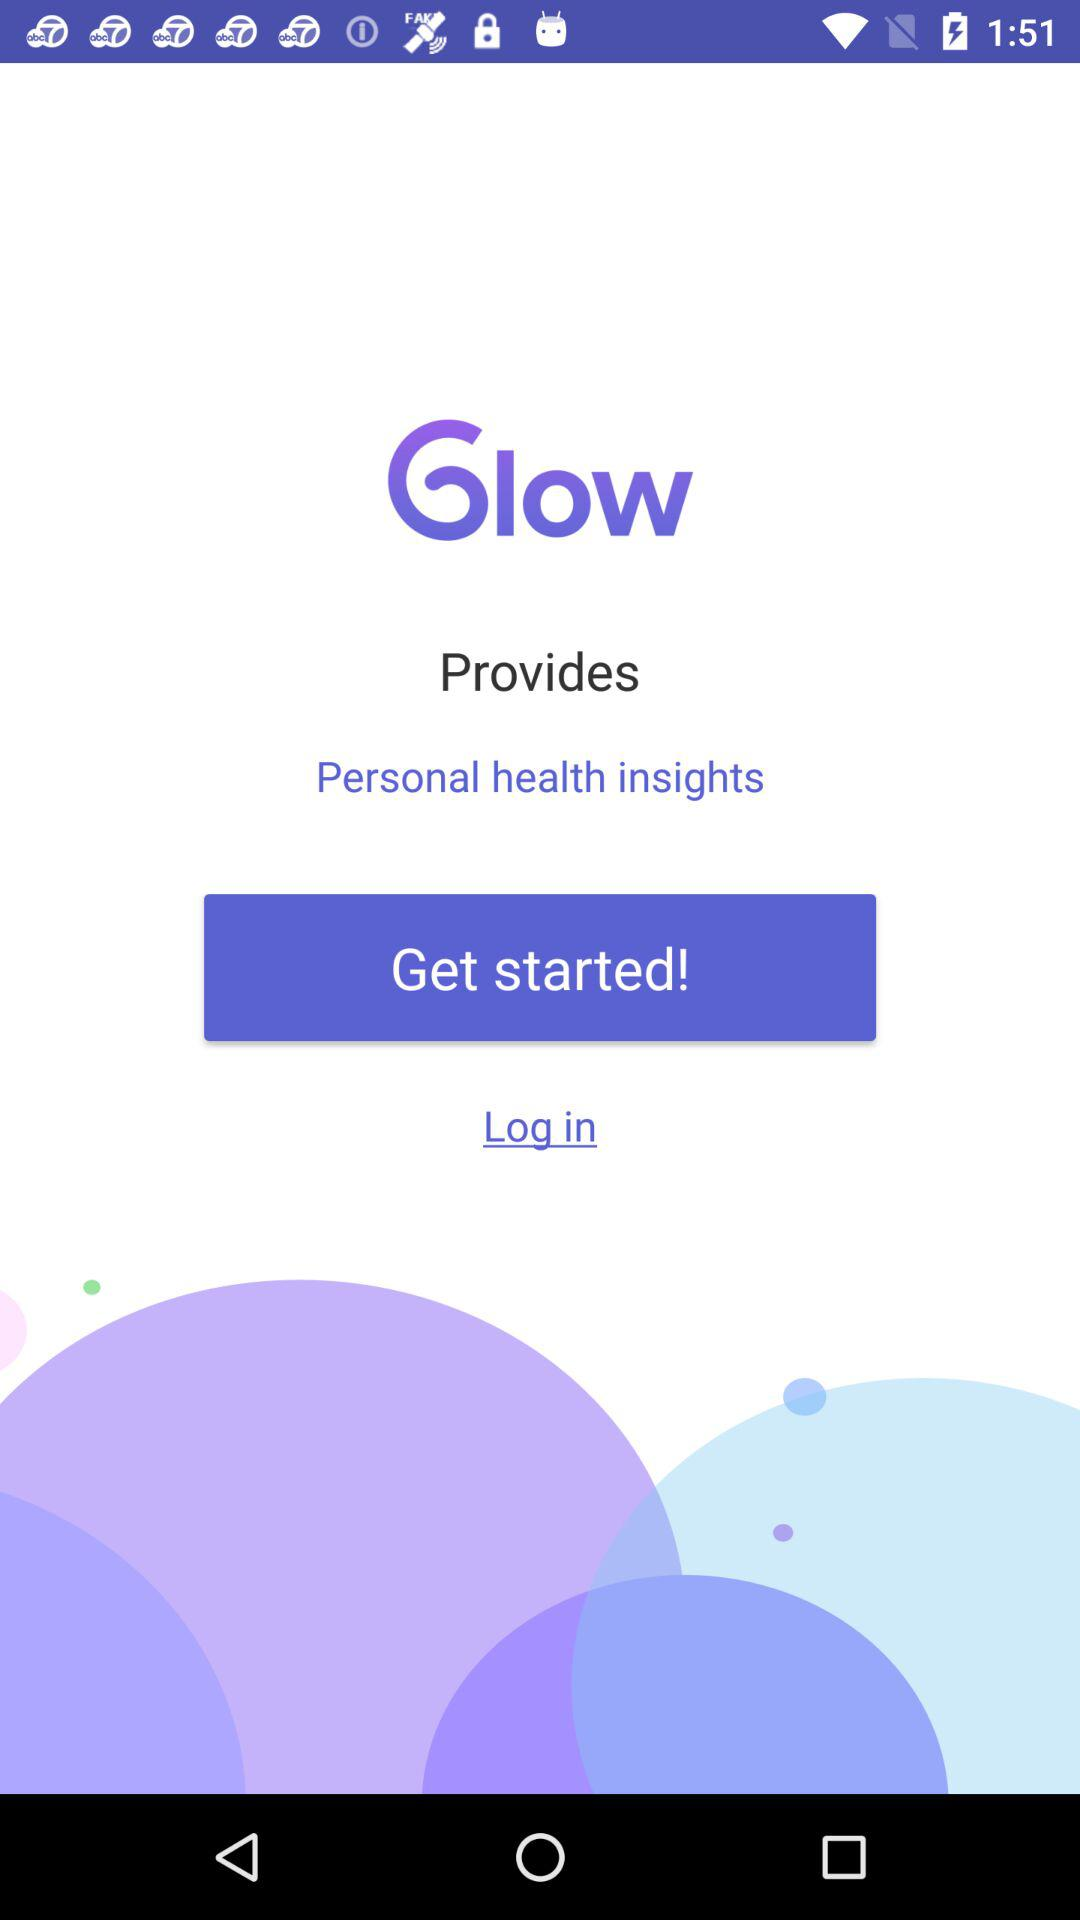What is the application name? The application name is "Glow". 